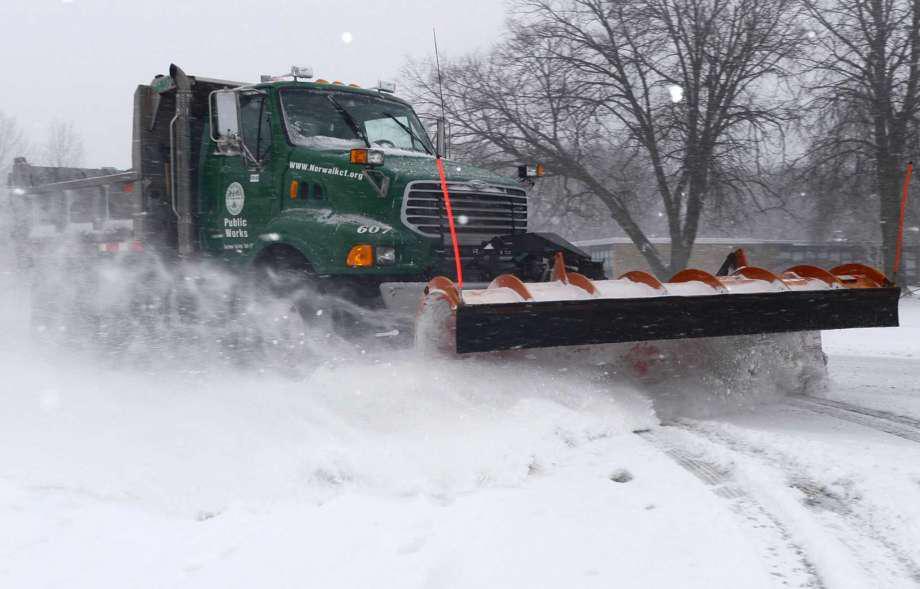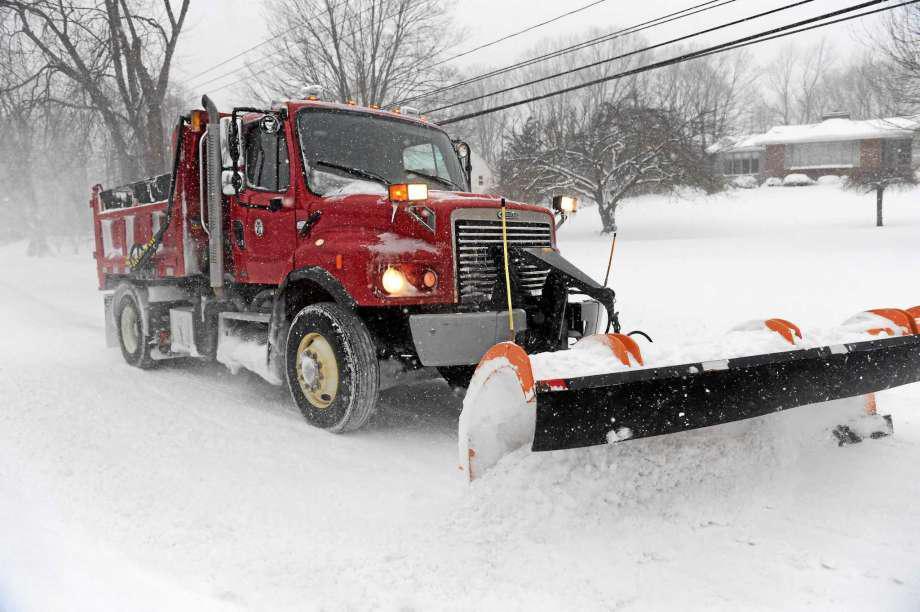The first image is the image on the left, the second image is the image on the right. Examine the images to the left and right. Is the description "Each image shows a truck with a red-orange front plow angled facing rightward, and one image features an orange truck pulling a plow." accurate? Answer yes or no. No. 